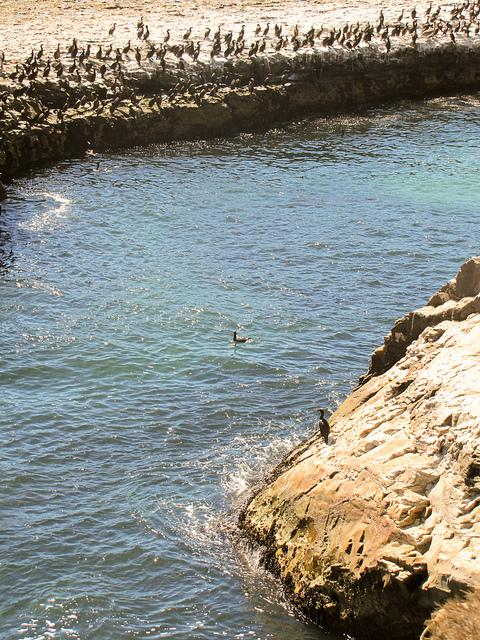What is usually found inside of the large blue item?

Choices:
A) flowers
B) soda
C) beef
D) fish fish 